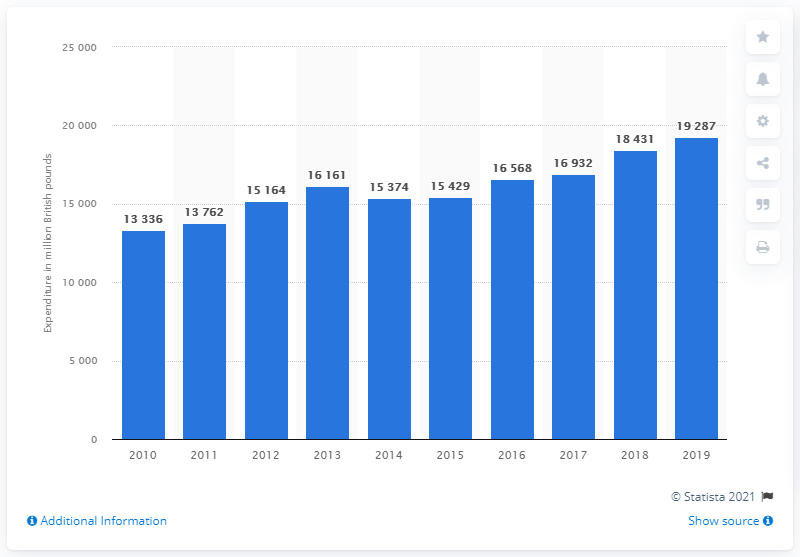Point out several critical features in this image. In 2019, the total expenditure on electricity by households in the UK was 19,287. 